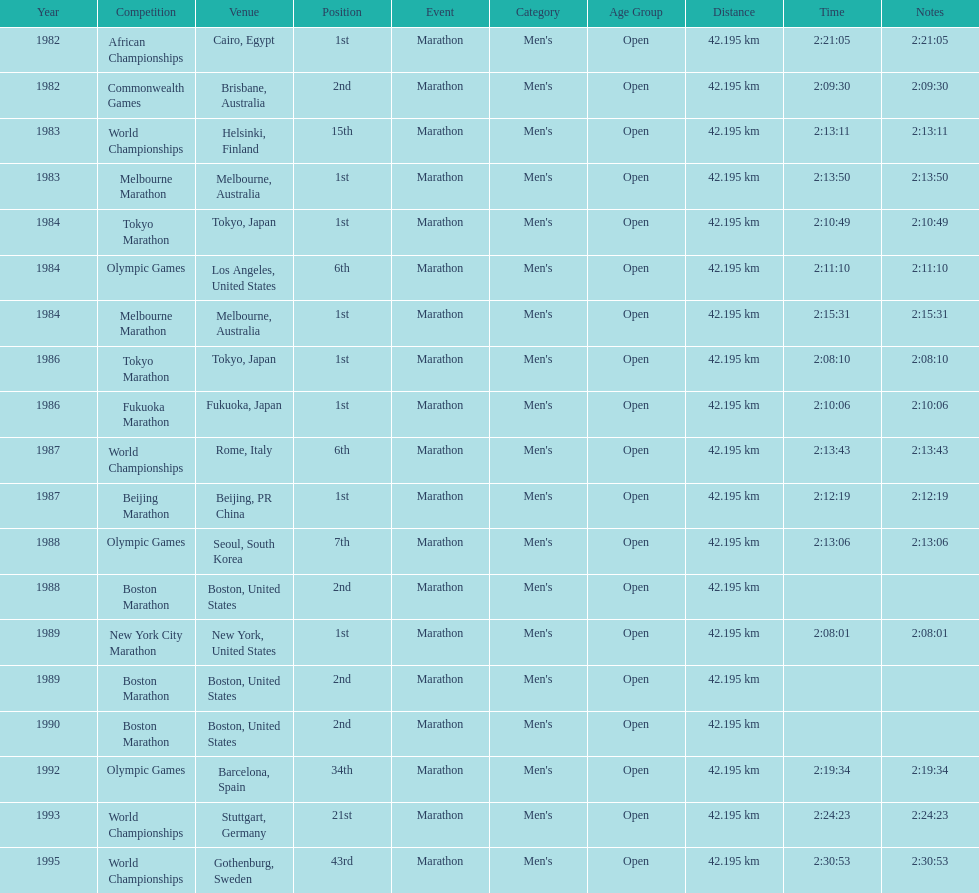How many times in total did ikangaa run the marathon in the olympic games? 3. 